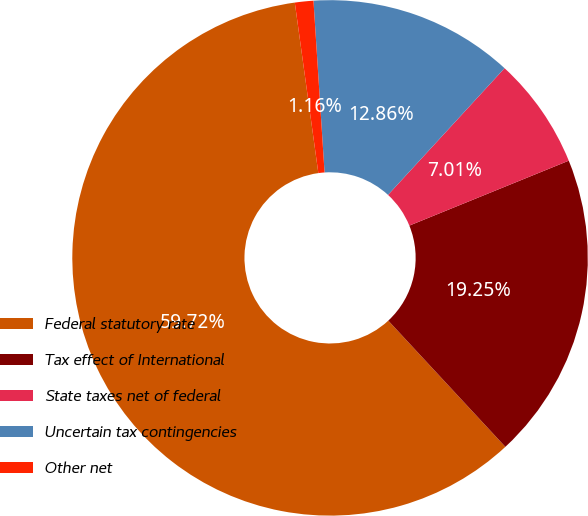Convert chart. <chart><loc_0><loc_0><loc_500><loc_500><pie_chart><fcel>Federal statutory rate<fcel>Tax effect of International<fcel>State taxes net of federal<fcel>Uncertain tax contingencies<fcel>Other net<nl><fcel>59.72%<fcel>19.25%<fcel>7.01%<fcel>12.86%<fcel>1.16%<nl></chart> 